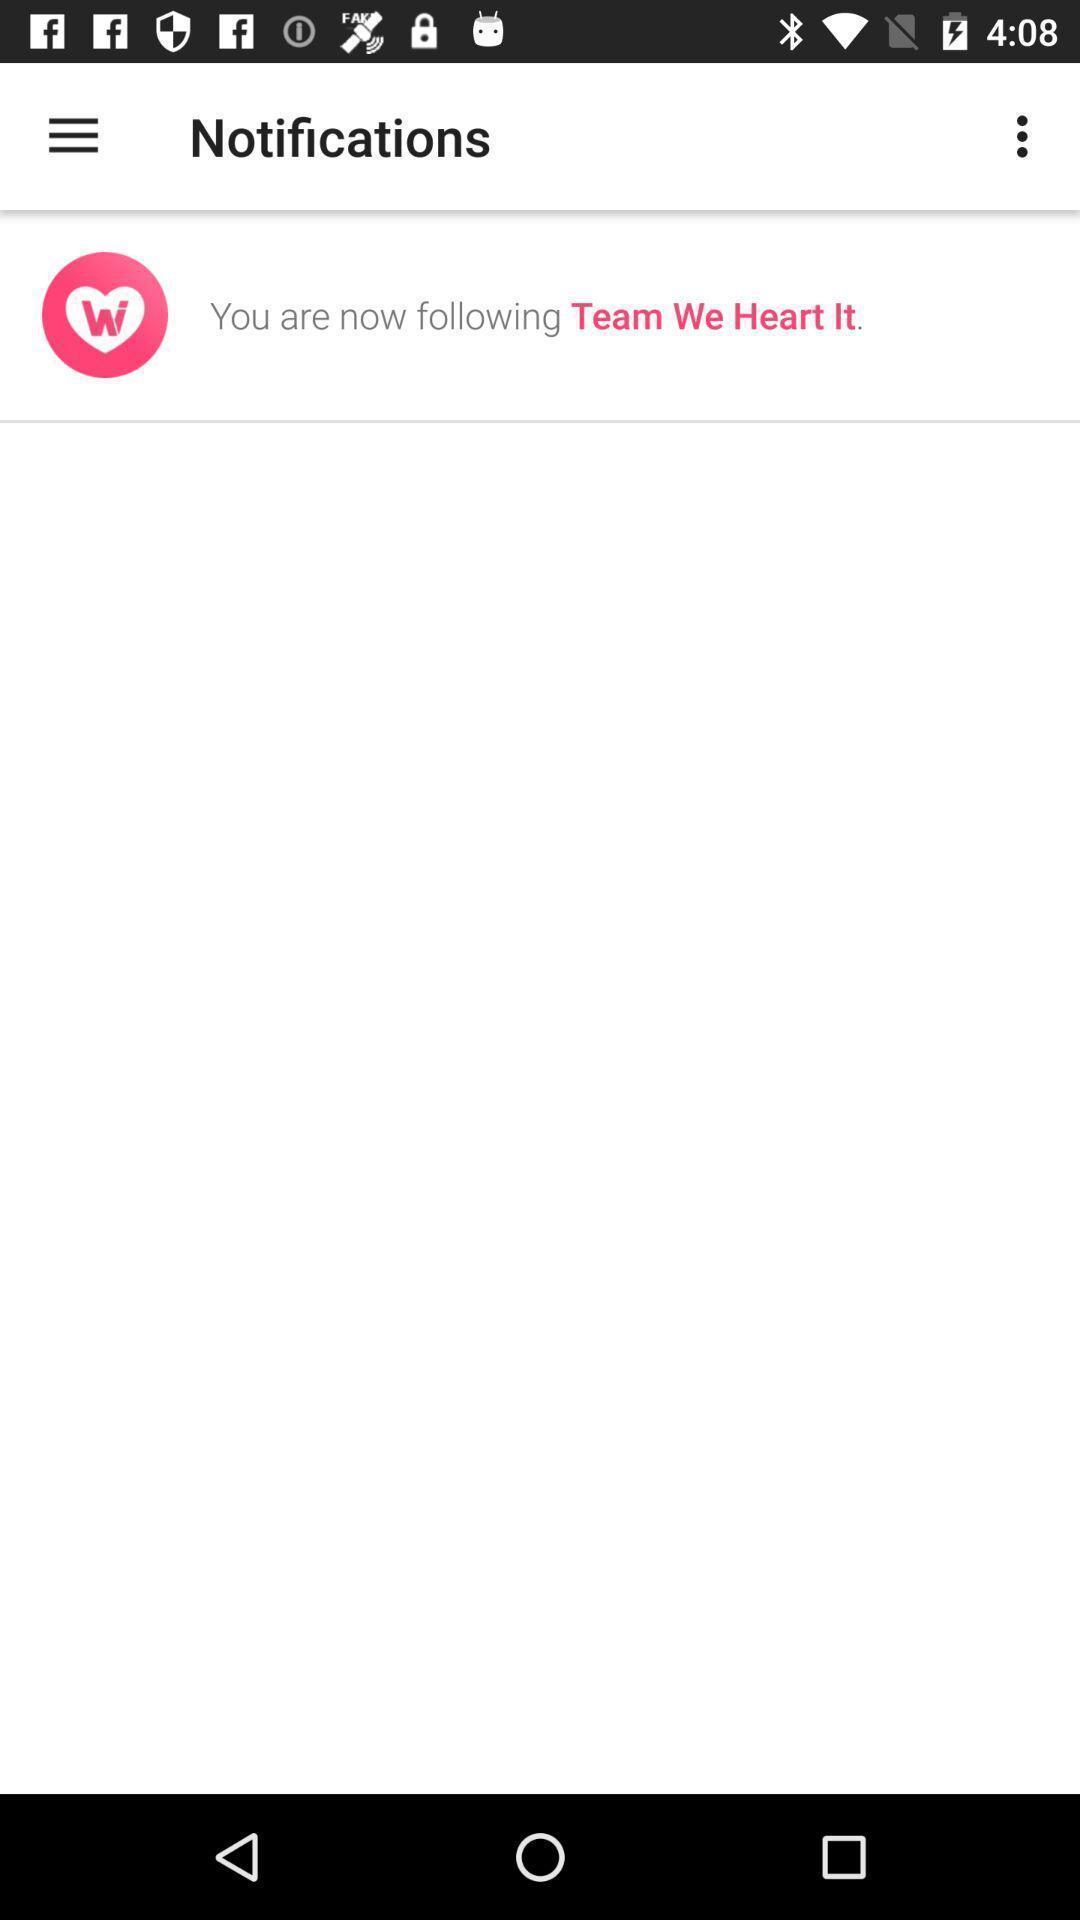What can you discern from this picture? Screen showing notifications. 